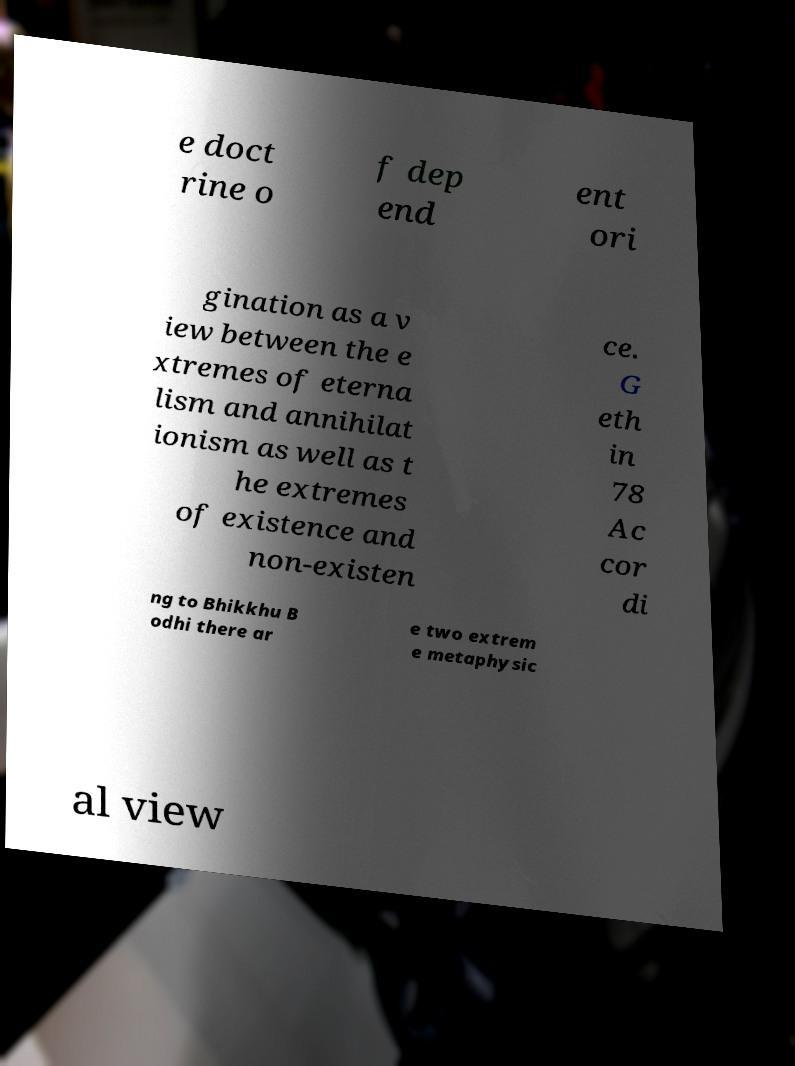What messages or text are displayed in this image? I need them in a readable, typed format. e doct rine o f dep end ent ori gination as a v iew between the e xtremes of eterna lism and annihilat ionism as well as t he extremes of existence and non-existen ce. G eth in 78 Ac cor di ng to Bhikkhu B odhi there ar e two extrem e metaphysic al view 